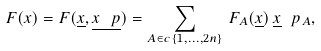Convert formula to latex. <formula><loc_0><loc_0><loc_500><loc_500>F ( { x } ) = F ( \underline { x } , \underline { x \ p } ) = \sum _ { A \in c \{ 1 , \dots , 2 n \} } \, F _ { A } ( \underline { x } ) \, \underline { x } \ p _ { A } ,</formula> 